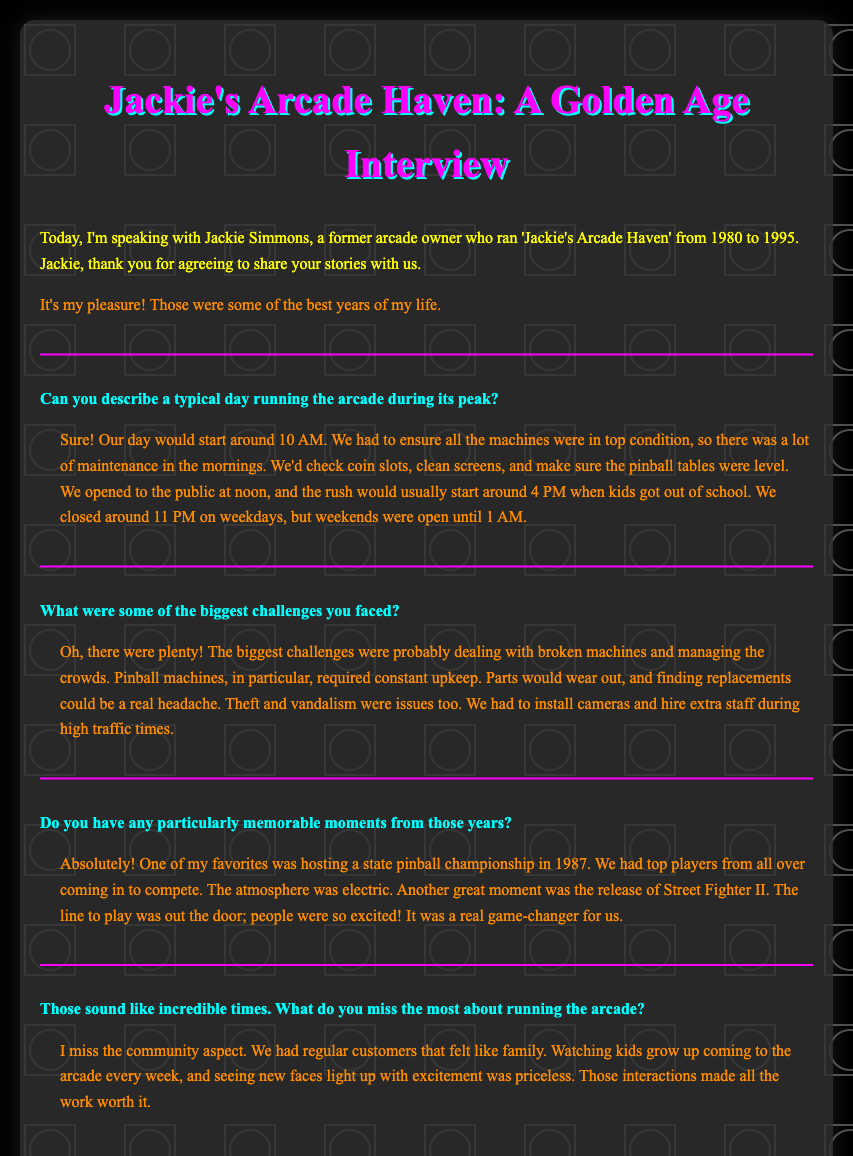What time did the arcade typically open? Jackie mentioned that they opened to the public at noon.
Answer: noon How long did Jackie run the arcade? Jackie stated that he ran 'Jackie's Arcade Haven' from 1980 to 1995, which is 15 years.
Answer: 15 years What was a significant event Jackie hosted in 1987? Jackie described hosting a state pinball championship as one of his favorite events.
Answer: state pinball championship What time did the arcade close on weekdays? Jackie noted that the arcade closed around 11 PM on weekdays.
Answer: 11 PM What were some challenges faced in maintenance? Jackie pointed out that broken machines and the constant upkeep of pinball machines were significant challenges.
Answer: broken machines, constant upkeep What feelings did Jackie associate with the community aspect of the arcade? Jackie expressed that regular customers felt like family, highlighting the importance of community.
Answer: family What was the release that drew large crowds? Jackie mentioned that the release of Street Fighter II had people lined out the door to play.
Answer: Street Fighter II What main aspect did Jackie miss after closing the arcade? Jackie stated he missed the community interaction and regular customers coming in.
Answer: community interaction 